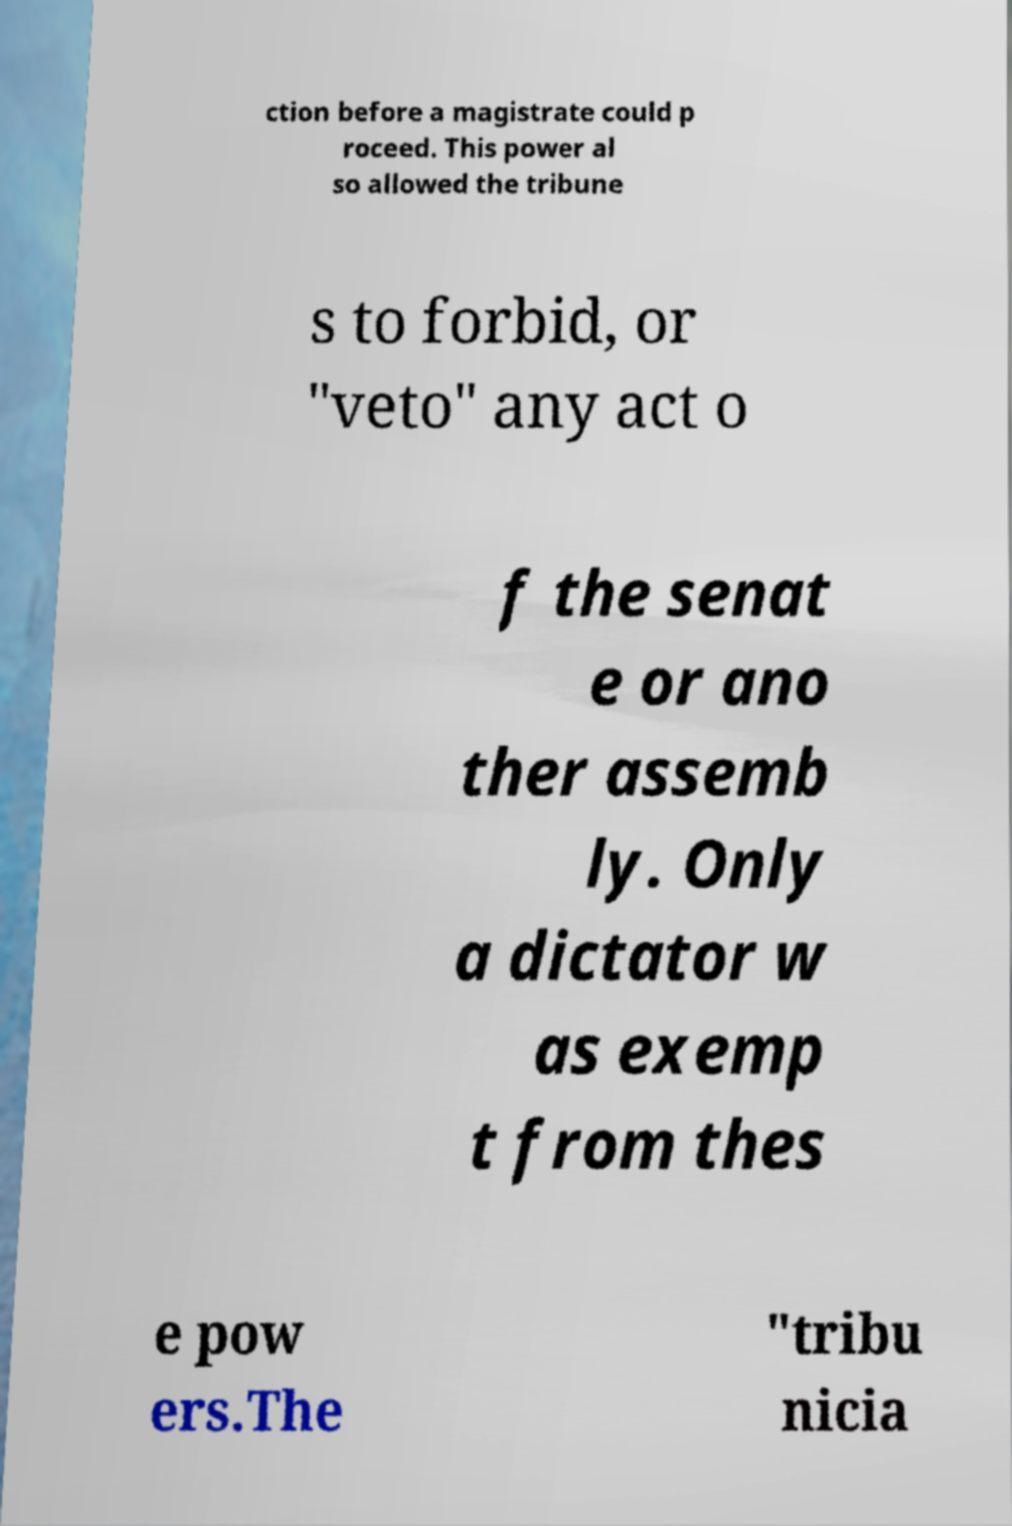I need the written content from this picture converted into text. Can you do that? ction before a magistrate could p roceed. This power al so allowed the tribune s to forbid, or "veto" any act o f the senat e or ano ther assemb ly. Only a dictator w as exemp t from thes e pow ers.The "tribu nicia 